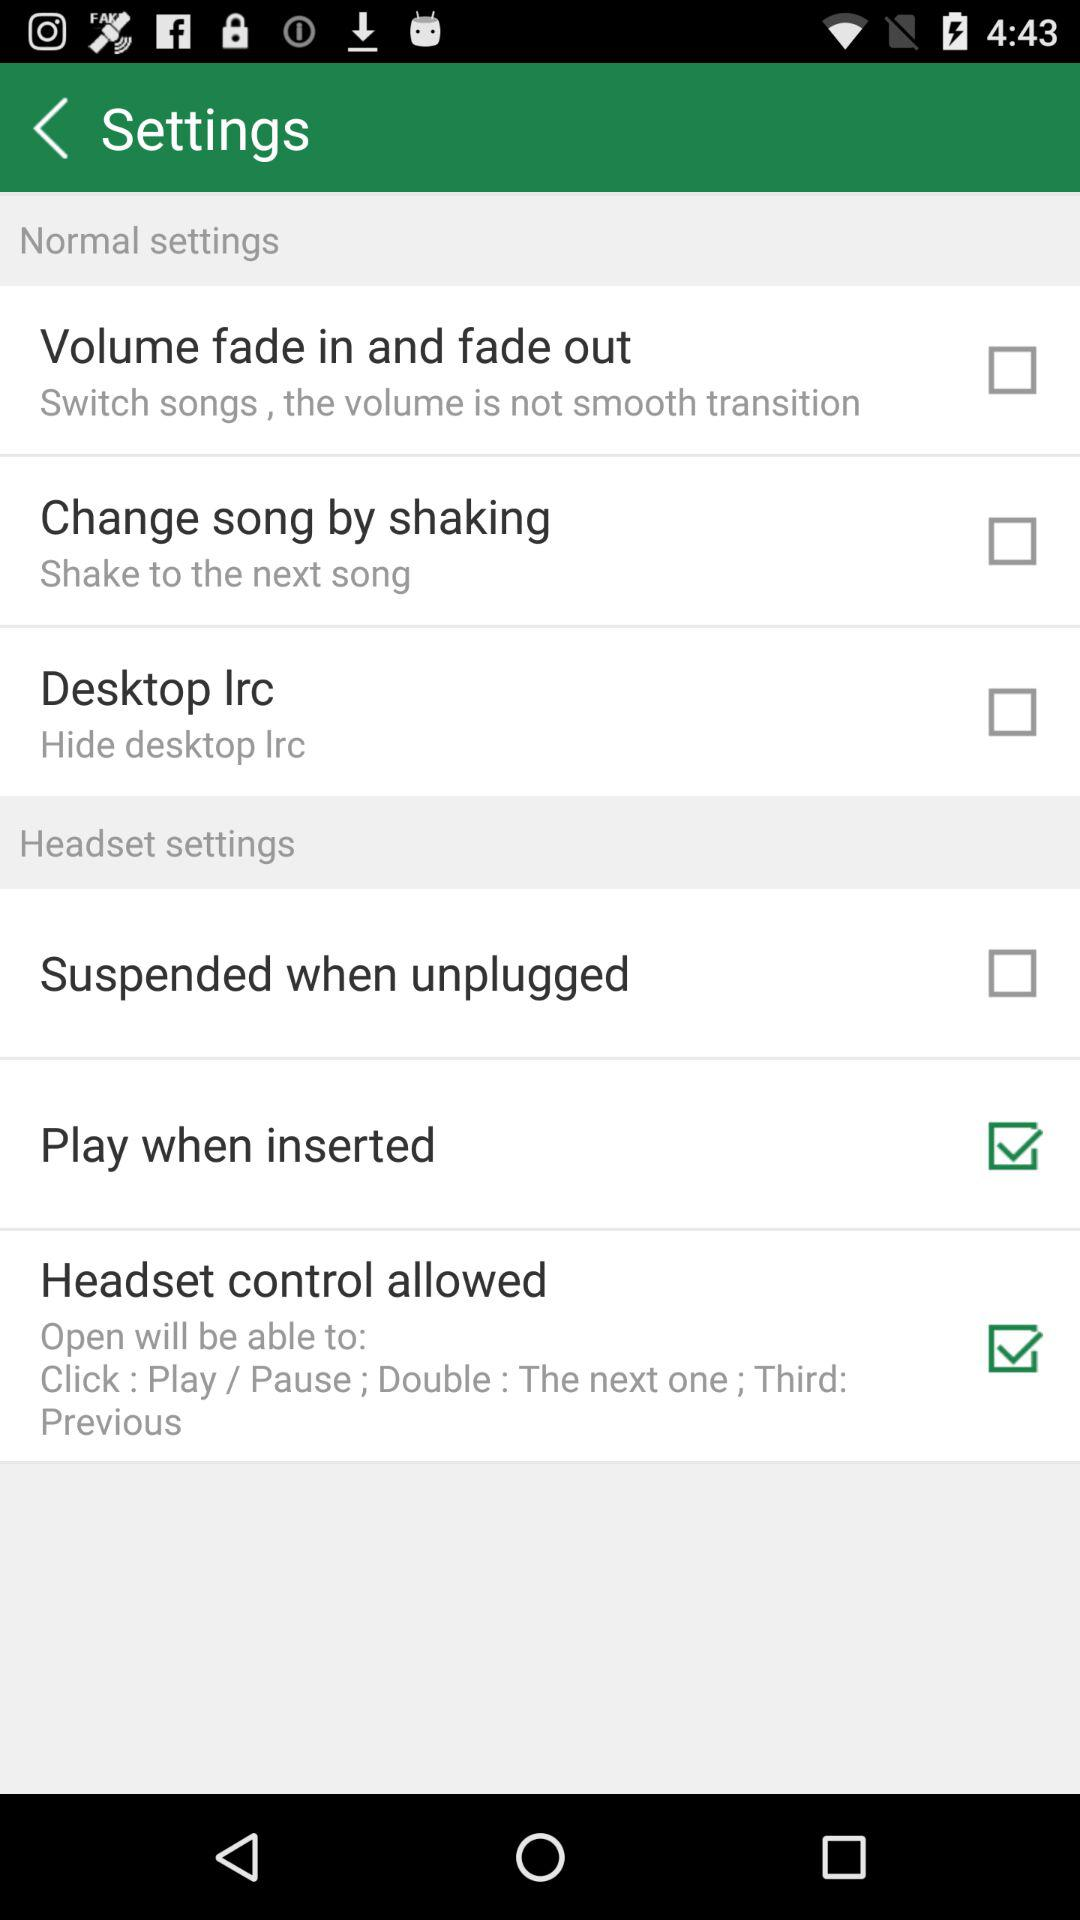What is the status of the "Change song by shaking"? The status is "off". 